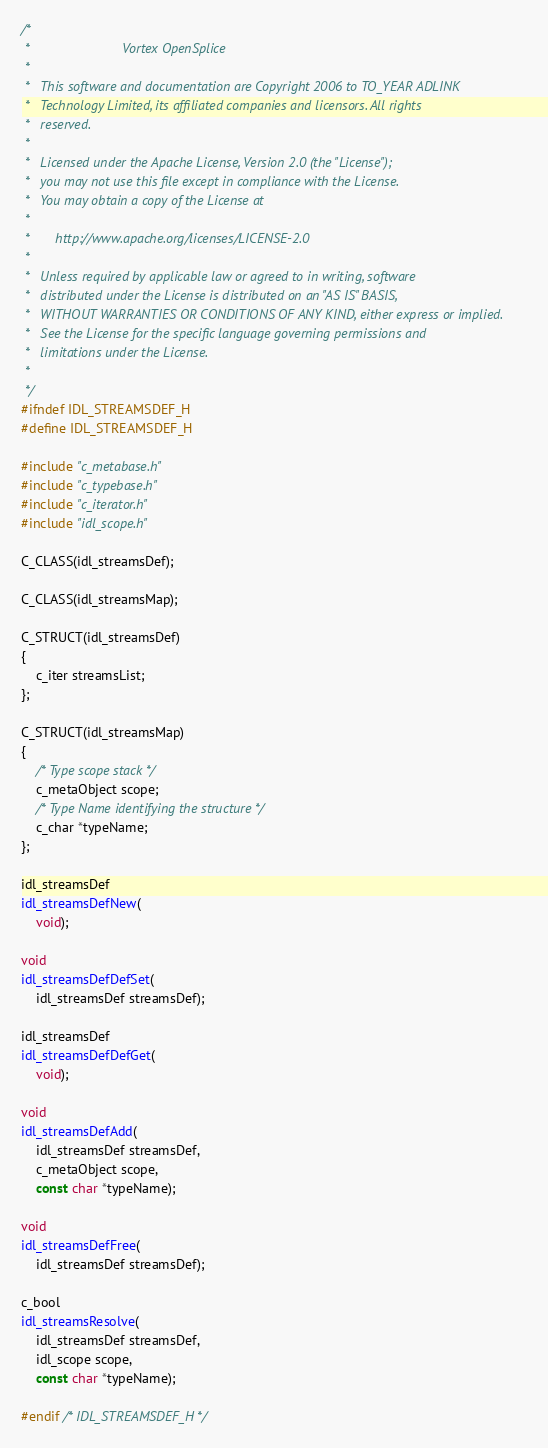Convert code to text. <code><loc_0><loc_0><loc_500><loc_500><_C_>/*
 *                         Vortex OpenSplice
 *
 *   This software and documentation are Copyright 2006 to TO_YEAR ADLINK
 *   Technology Limited, its affiliated companies and licensors. All rights
 *   reserved.
 *
 *   Licensed under the Apache License, Version 2.0 (the "License");
 *   you may not use this file except in compliance with the License.
 *   You may obtain a copy of the License at
 *
 *       http://www.apache.org/licenses/LICENSE-2.0
 *
 *   Unless required by applicable law or agreed to in writing, software
 *   distributed under the License is distributed on an "AS IS" BASIS,
 *   WITHOUT WARRANTIES OR CONDITIONS OF ANY KIND, either express or implied.
 *   See the License for the specific language governing permissions and
 *   limitations under the License.
 *
 */
#ifndef IDL_STREAMSDEF_H
#define IDL_STREAMSDEF_H

#include "c_metabase.h"
#include "c_typebase.h"
#include "c_iterator.h"
#include "idl_scope.h"

C_CLASS(idl_streamsDef);

C_CLASS(idl_streamsMap);

C_STRUCT(idl_streamsDef)
{
    c_iter streamsList;
};

C_STRUCT(idl_streamsMap)
{
    /* Type scope stack */
    c_metaObject scope;
    /* Type Name identifying the structure */
    c_char *typeName;
};

idl_streamsDef
idl_streamsDefNew(
    void);

void
idl_streamsDefDefSet(
    idl_streamsDef streamsDef);

idl_streamsDef
idl_streamsDefDefGet(
    void);

void
idl_streamsDefAdd(
    idl_streamsDef streamsDef,
    c_metaObject scope,
    const char *typeName);

void
idl_streamsDefFree(
    idl_streamsDef streamsDef);

c_bool
idl_streamsResolve(
    idl_streamsDef streamsDef,
    idl_scope scope,
    const char *typeName);

#endif /* IDL_STREAMSDEF_H */
</code> 